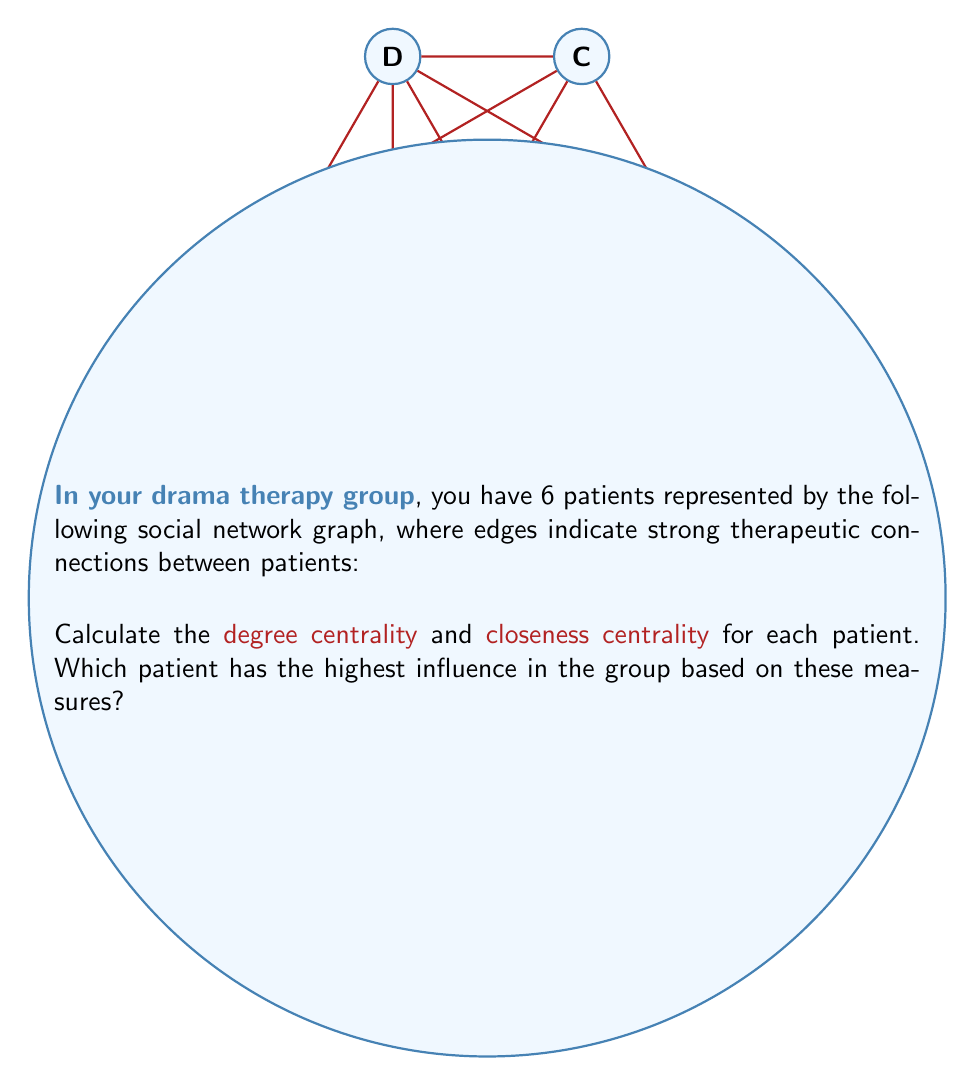Help me with this question. To solve this problem, we need to calculate two centrality measures for each patient:

1. Degree Centrality:
Degree centrality is the number of direct connections a node has.
A: 4, B: 3, C: 4, D: 5, E: 3, F: 3

2. Closeness Centrality:
Closeness centrality measures how close a node is to all other nodes in the network.

For each patient, we calculate:
$C_C(v) = \frac{n-1}{\sum_{u \neq v} d(u,v)}$

Where $n$ is the number of nodes, and $d(u,v)$ is the shortest path between nodes $u$ and $v$.

Calculating shortest paths:
A: 1,1,1,1,2 (sum = 6)
B: 1,1,1,2,2 (sum = 7)
C: 1,1,1,1,2 (sum = 6)
D: 1,1,1,1,1 (sum = 5)
E: 2,1,1,1,2 (sum = 7)
F: 2,2,1,1,1 (sum = 7)

Closeness Centrality:
A: $\frac{5}{6} \approx 0.833$
B: $\frac{5}{7} \approx 0.714$
C: $\frac{5}{6} \approx 0.833$
D: $\frac{5}{5} = 1.000$
E: $\frac{5}{7} \approx 0.714$
F: $\frac{5}{7} \approx 0.714$

Based on both measures, patient D has the highest degree centrality (5) and the highest closeness centrality (1.000), indicating the highest influence in the group.
Answer: Patient D 